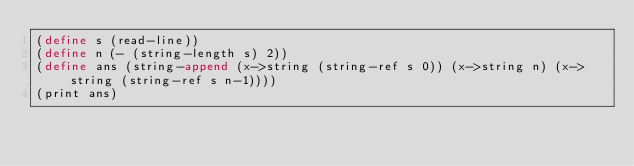Convert code to text. <code><loc_0><loc_0><loc_500><loc_500><_Scheme_>(define s (read-line))
(define n (- (string-length s) 2))
(define ans (string-append (x->string (string-ref s 0)) (x->string n) (x->string (string-ref s n-1))))
(print ans)
</code> 